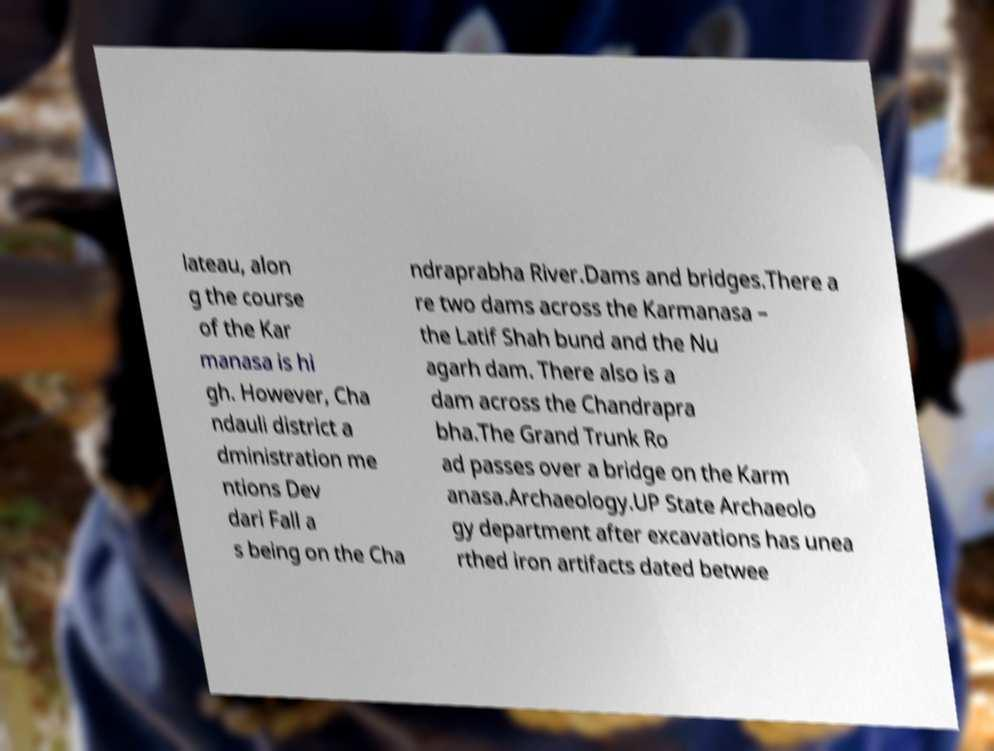Please identify and transcribe the text found in this image. lateau, alon g the course of the Kar manasa is hi gh. However, Cha ndauli district a dministration me ntions Dev dari Fall a s being on the Cha ndraprabha River.Dams and bridges.There a re two dams across the Karmanasa – the Latif Shah bund and the Nu agarh dam. There also is a dam across the Chandrapra bha.The Grand Trunk Ro ad passes over a bridge on the Karm anasa.Archaeology.UP State Archaeolo gy department after excavations has unea rthed iron artifacts dated betwee 